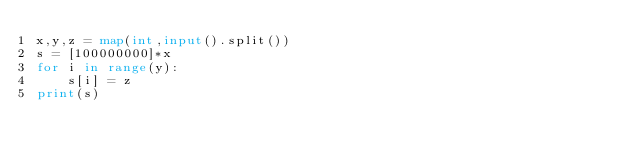Convert code to text. <code><loc_0><loc_0><loc_500><loc_500><_Python_>x,y,z = map(int,input().split())
s = [100000000]*x
for i in range(y):
    s[i] = z
print(s)</code> 